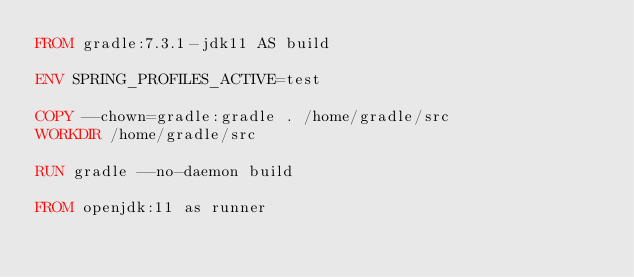<code> <loc_0><loc_0><loc_500><loc_500><_Dockerfile_>FROM gradle:7.3.1-jdk11 AS build

ENV SPRING_PROFILES_ACTIVE=test

COPY --chown=gradle:gradle . /home/gradle/src
WORKDIR /home/gradle/src

RUN gradle --no-daemon build

FROM openjdk:11 as runner
</code> 